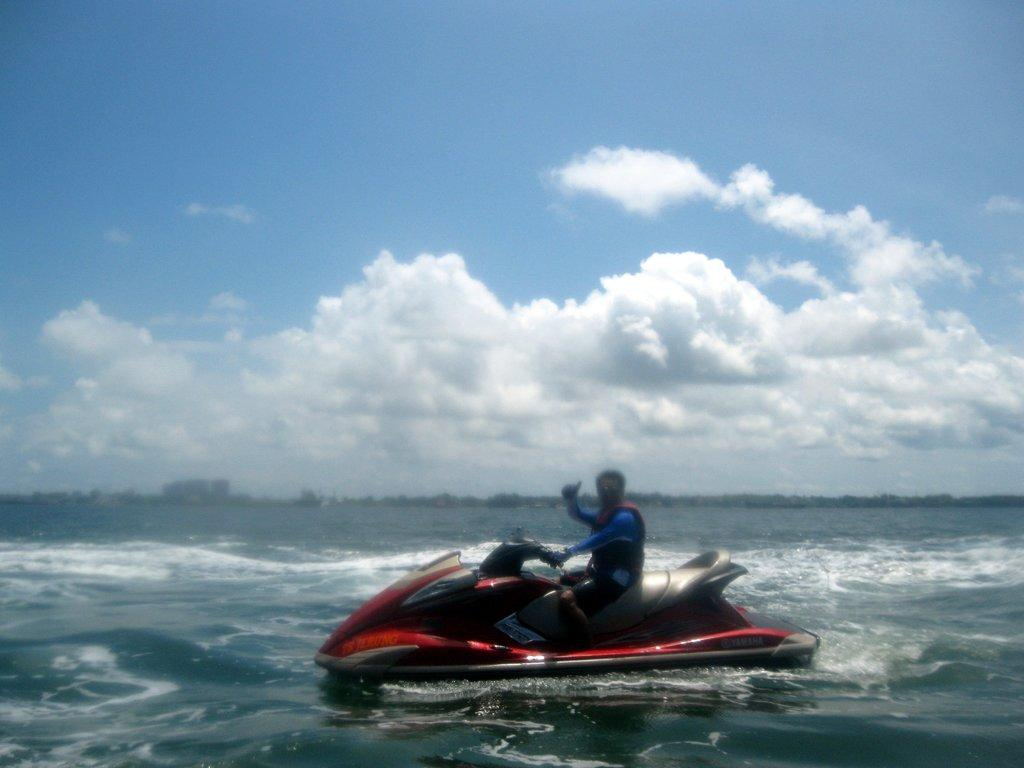What is the person in the image doing? There is a person sitting on a boat in the image. How is the boat positioned in relation to the water? The boat is above the water in the image. What can be seen in the background of the image? The sky in the background is cloudy. What type of shoe is the person wearing while sitting on the boat? There is no information about the person's footwear in the image, so it cannot be determined what type of shoe they might be wearing. 